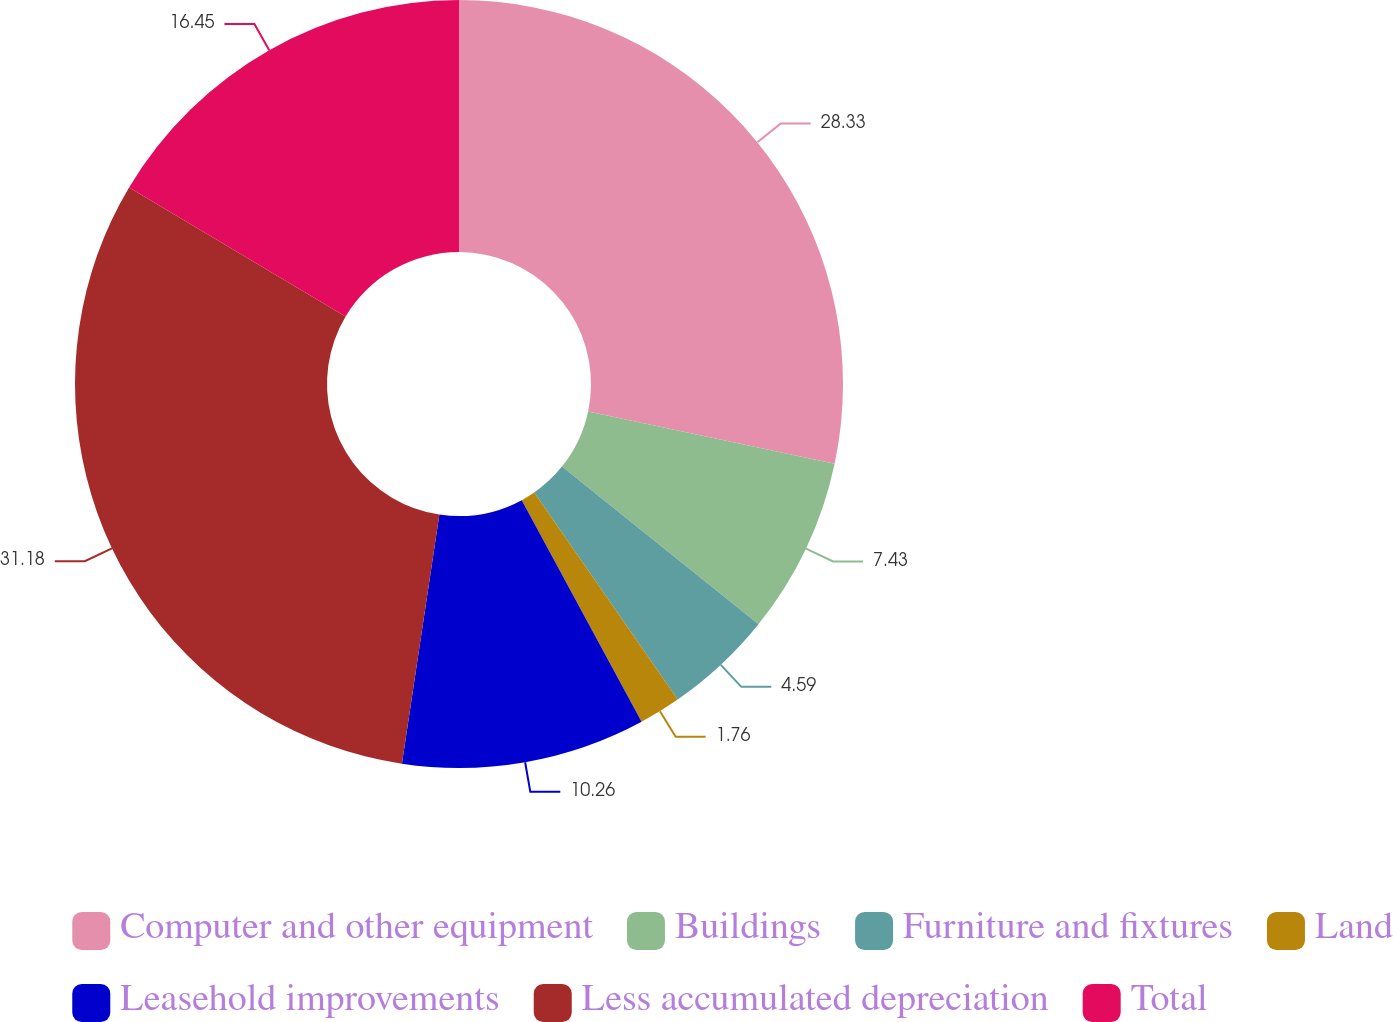Convert chart to OTSL. <chart><loc_0><loc_0><loc_500><loc_500><pie_chart><fcel>Computer and other equipment<fcel>Buildings<fcel>Furniture and fixtures<fcel>Land<fcel>Leasehold improvements<fcel>Less accumulated depreciation<fcel>Total<nl><fcel>28.33%<fcel>7.43%<fcel>4.59%<fcel>1.76%<fcel>10.26%<fcel>31.17%<fcel>16.45%<nl></chart> 